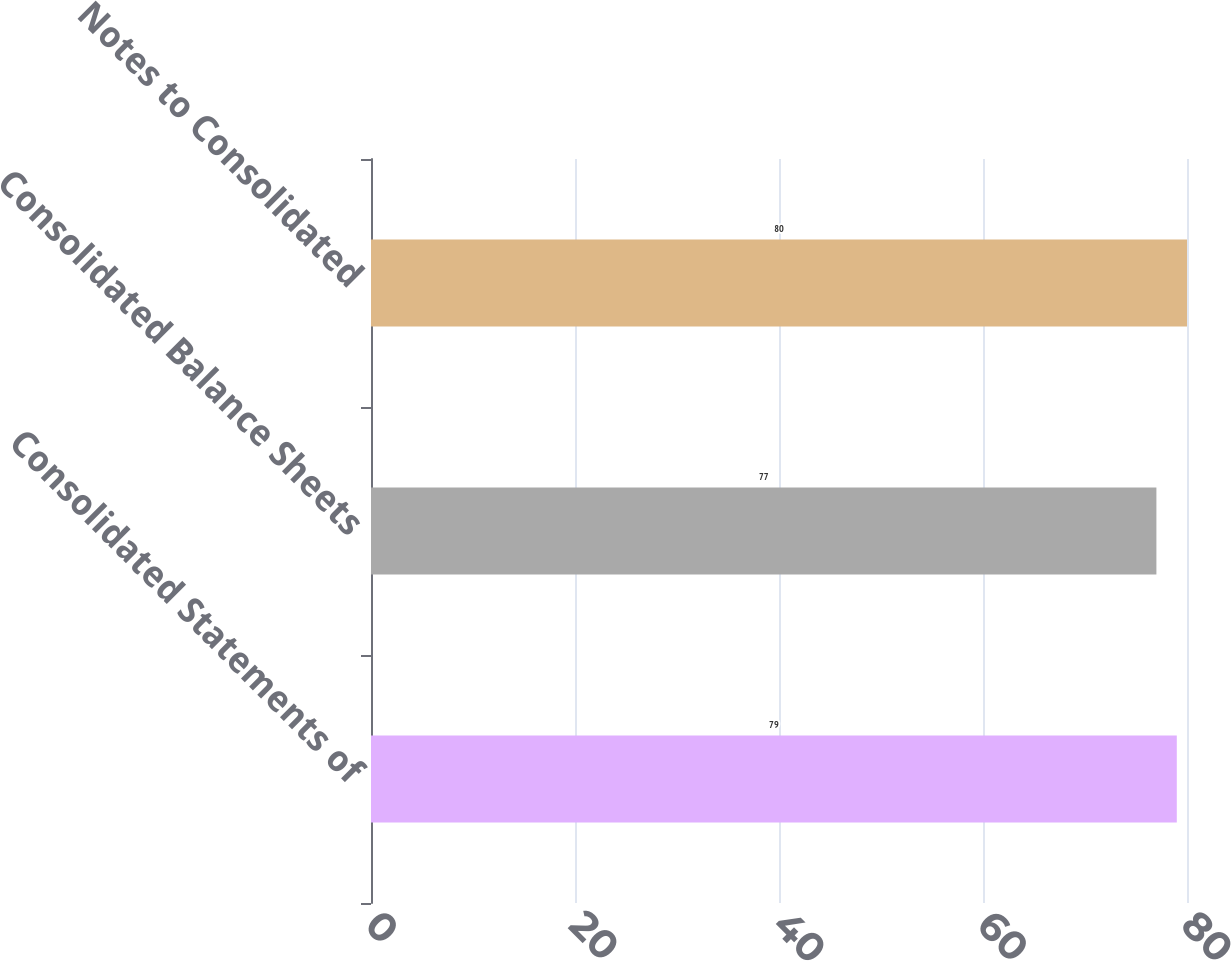Convert chart to OTSL. <chart><loc_0><loc_0><loc_500><loc_500><bar_chart><fcel>Consolidated Statements of<fcel>Consolidated Balance Sheets<fcel>Notes to Consolidated<nl><fcel>79<fcel>77<fcel>80<nl></chart> 